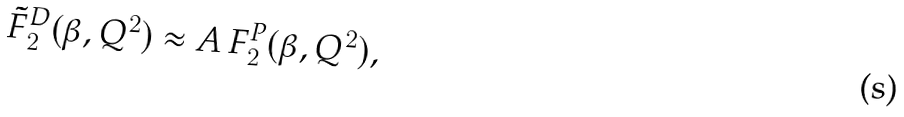<formula> <loc_0><loc_0><loc_500><loc_500>\tilde { F } _ { 2 } ^ { D } ( \beta , Q ^ { 2 } ) \approx A \, F _ { 2 } ^ { P } ( \beta , Q ^ { 2 } ) ,</formula> 